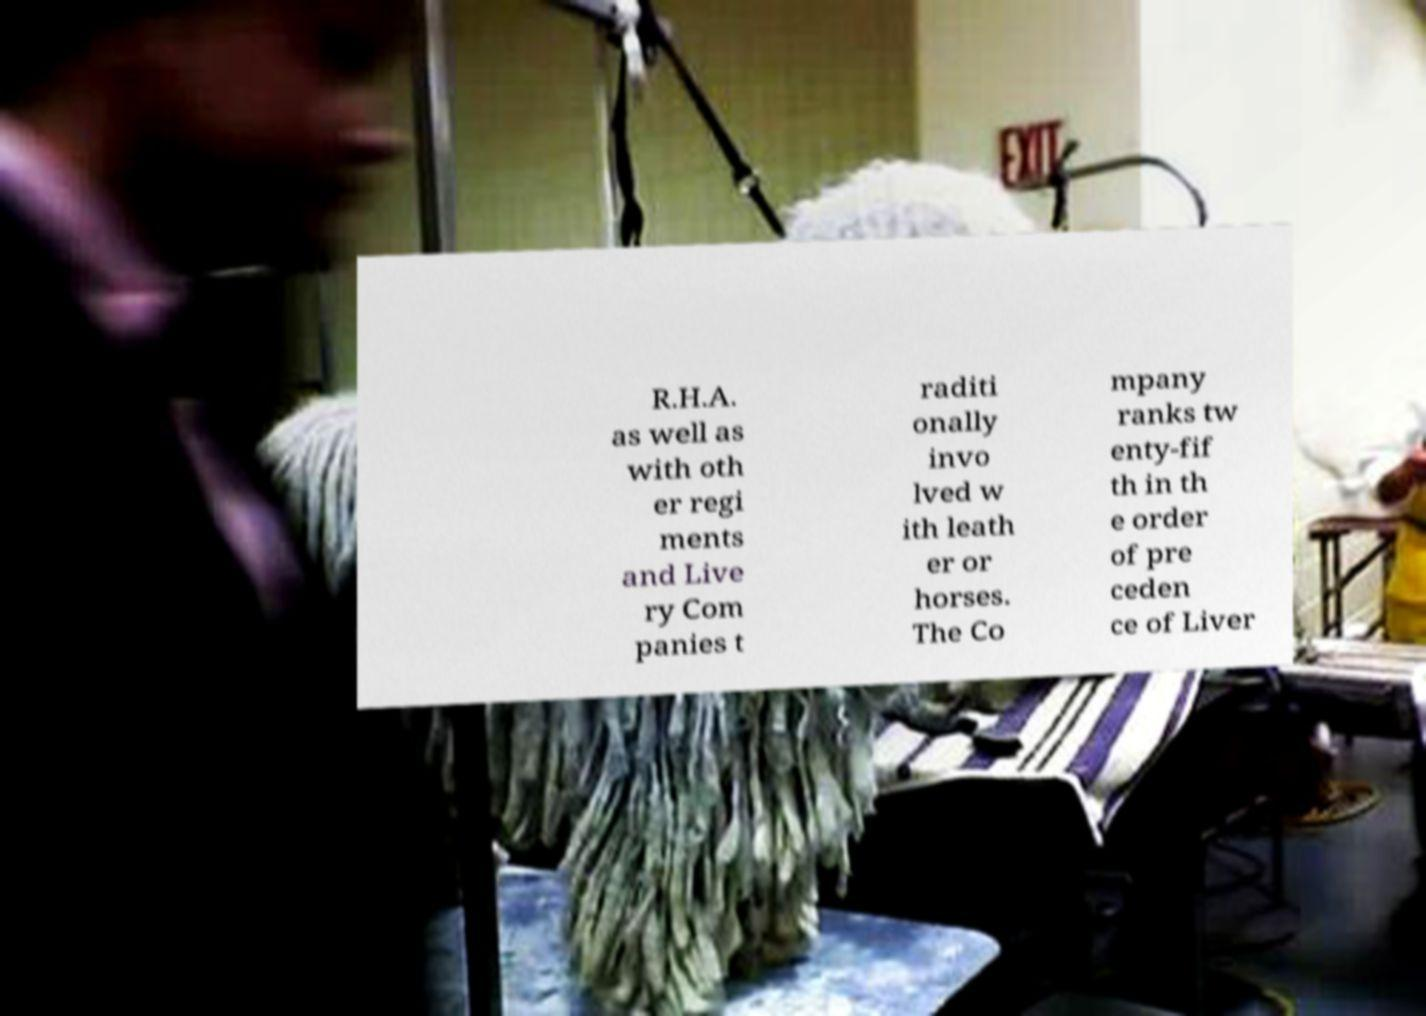Could you assist in decoding the text presented in this image and type it out clearly? R.H.A. as well as with oth er regi ments and Live ry Com panies t raditi onally invo lved w ith leath er or horses. The Co mpany ranks tw enty-fif th in th e order of pre ceden ce of Liver 